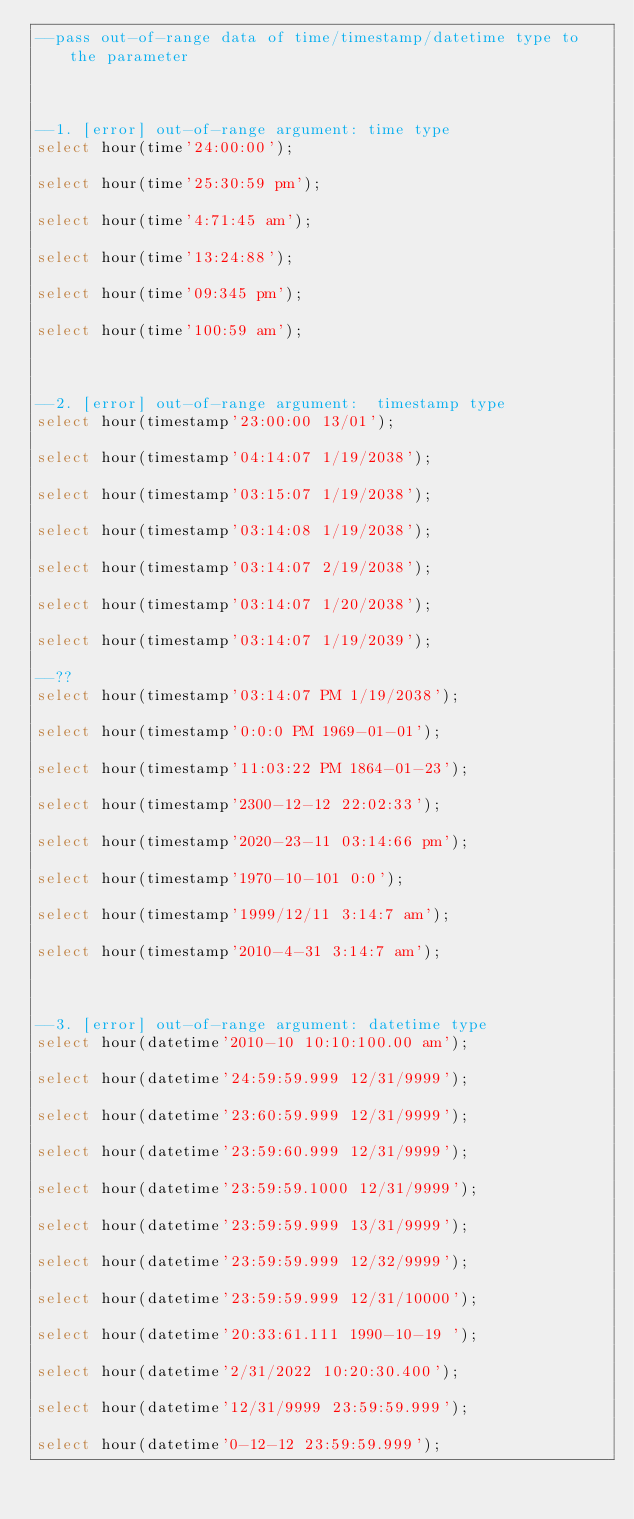<code> <loc_0><loc_0><loc_500><loc_500><_SQL_>--pass out-of-range data of time/timestamp/datetime type to the parameter



--1. [error] out-of-range argument: time type
select hour(time'24:00:00');

select hour(time'25:30:59 pm');

select hour(time'4:71:45 am');

select hour(time'13:24:88');

select hour(time'09:345 pm');

select hour(time'100:59 am');



--2. [error] out-of-range argument:  timestamp type
select hour(timestamp'23:00:00 13/01');

select hour(timestamp'04:14:07 1/19/2038');

select hour(timestamp'03:15:07 1/19/2038');

select hour(timestamp'03:14:08 1/19/2038');

select hour(timestamp'03:14:07 2/19/2038');

select hour(timestamp'03:14:07 1/20/2038');

select hour(timestamp'03:14:07 1/19/2039');

--??
select hour(timestamp'03:14:07 PM 1/19/2038');

select hour(timestamp'0:0:0 PM 1969-01-01');

select hour(timestamp'11:03:22 PM 1864-01-23');

select hour(timestamp'2300-12-12 22:02:33');

select hour(timestamp'2020-23-11 03:14:66 pm');

select hour(timestamp'1970-10-101 0:0');

select hour(timestamp'1999/12/11 3:14:7 am');

select hour(timestamp'2010-4-31 3:14:7 am');



--3. [error] out-of-range argument: datetime type
select hour(datetime'2010-10 10:10:100.00 am');

select hour(datetime'24:59:59.999 12/31/9999');

select hour(datetime'23:60:59.999 12/31/9999');

select hour(datetime'23:59:60.999 12/31/9999');

select hour(datetime'23:59:59.1000 12/31/9999');

select hour(datetime'23:59:59.999 13/31/9999');

select hour(datetime'23:59:59.999 12/32/9999');

select hour(datetime'23:59:59.999 12/31/10000');

select hour(datetime'20:33:61.111 1990-10-19 ');

select hour(datetime'2/31/2022 10:20:30.400');

select hour(datetime'12/31/9999 23:59:59.999');

select hour(datetime'0-12-12 23:59:59.999');

</code> 